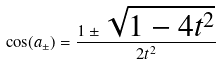<formula> <loc_0><loc_0><loc_500><loc_500>\cos ( a _ { \pm } ) = \frac { 1 \pm \sqrt { 1 - 4 t ^ { 2 } } } { 2 t ^ { 2 } }</formula> 